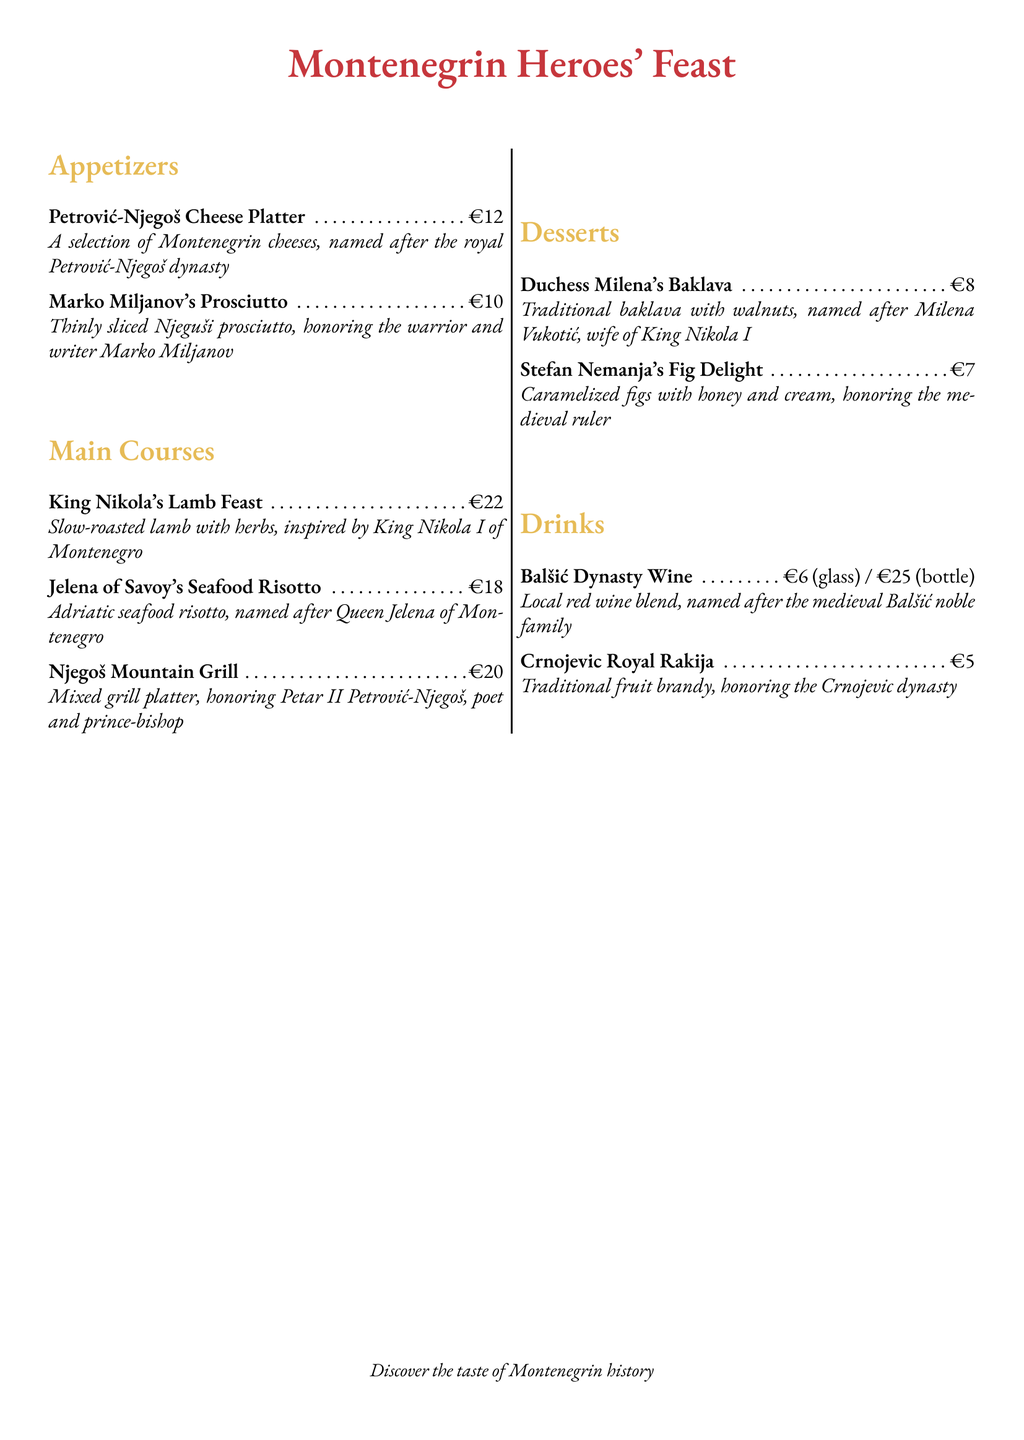What is the name of the cheese platter? The menu lists a cheese platter named after the Petrović-Njegoš dynasty.
Answer: Petrović-Njegoš Cheese Platter Who does the prosciutto honor? The prosciutto is named after the warrior and writer Marko Miljanov.
Answer: Marko Miljanov What is the price of King Nikola's Lamb Feast? The price is clearly stated in euros next to the dish in the menu.
Answer: €22 What type of dish is Jelena of Savoy's Seafood Risotto? The description specifies that it is a risotto made with Adriatic seafood.
Answer: Seafood Risotto How much is the Balšić Dynasty Wine per bottle? The menu provides a specific price for the bottle of wine listed.
Answer: €25 (bottle) What dessert is named after Milena Vukotić? The dessert is a traditional baklava associated with Milena Vukotić.
Answer: Duchess Milena's Baklava What is the main ingredient in Stefan Nemanja's Fig Delight? The main ingredient mentioned in the description is figs.
Answer: Figs Which drink honors the Crnojevic dynasty? The drink specifically named after the Crnojevic dynasty is a type of fruit brandy.
Answer: Crnojevic Royal Rakija 